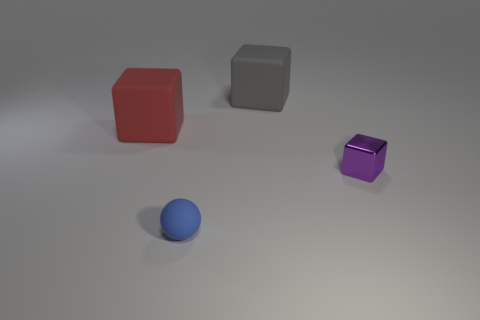What materials appear to have been used for the objects in this scene? The objects in the scene appear to consist of different materials— the red and grey cubes exhibit a matte finish, suggesting a non-reflective, possibly plastic or painted surface. The purple object, depending on the lighting and color saturation, seems to have a metallic finish with a subtle sheen, indicating it might be made of metal. 